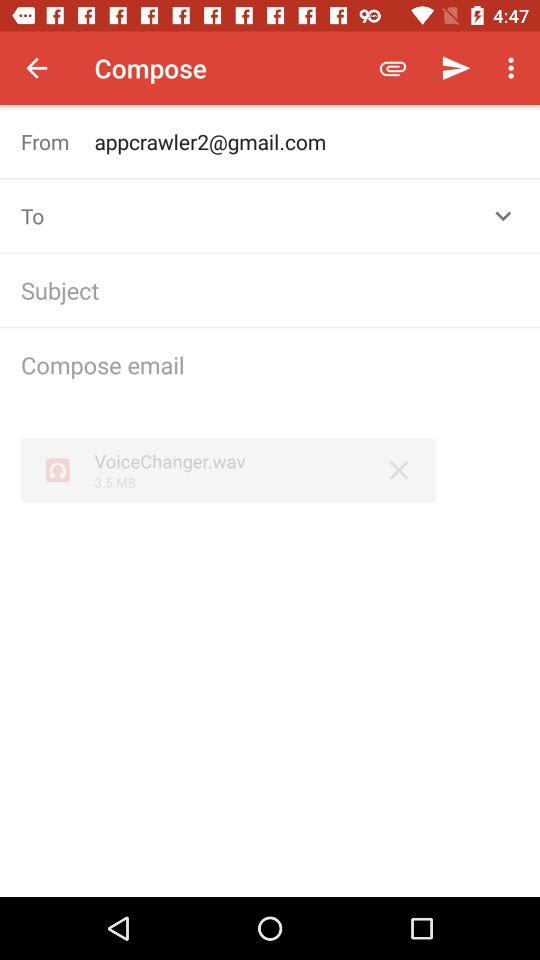What Gmail address is used to compose mail? The Gmail address is appcrawler2@gmail.com. 